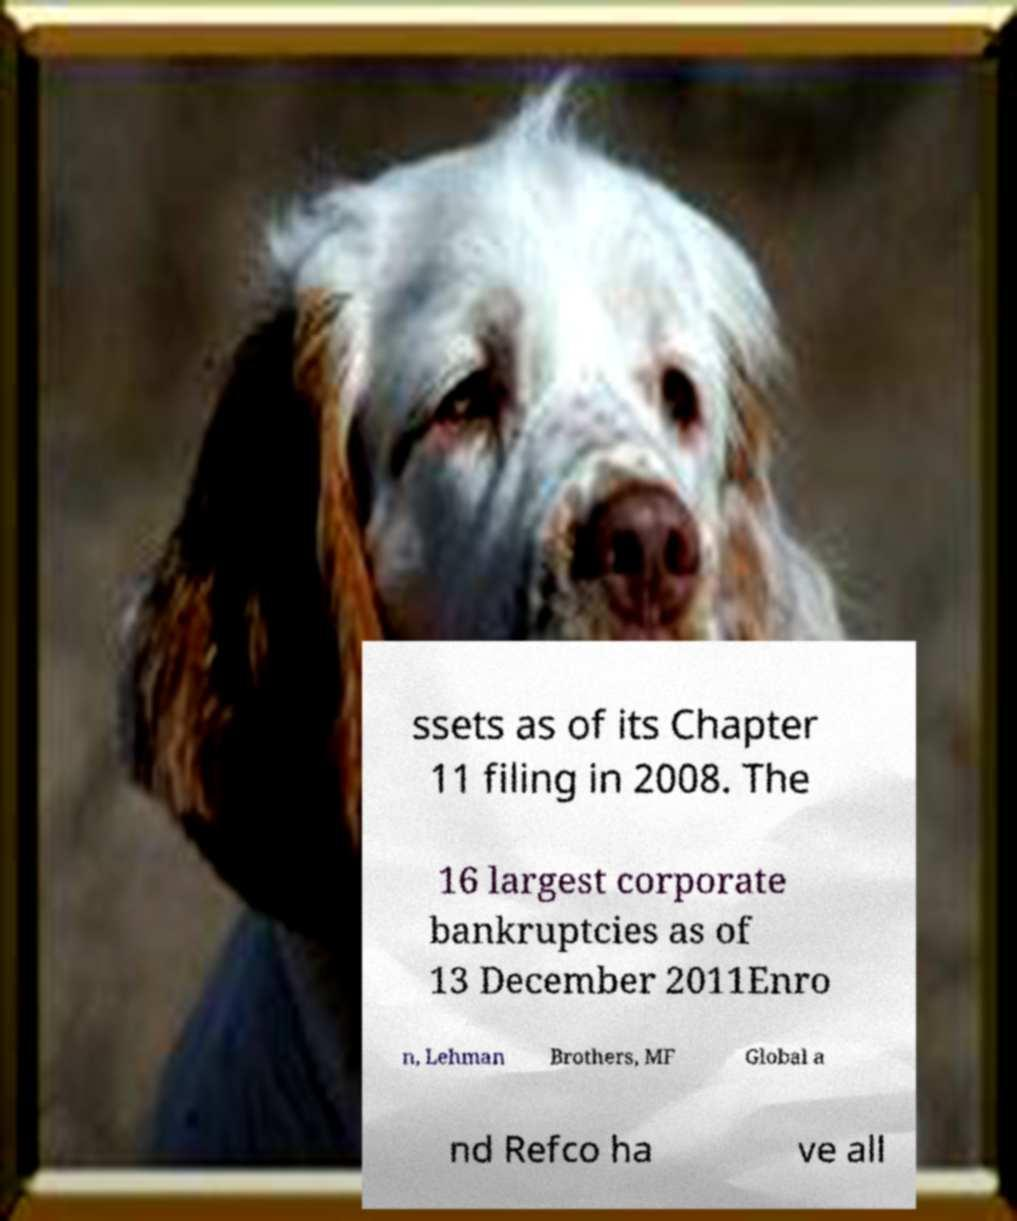What messages or text are displayed in this image? I need them in a readable, typed format. ssets as of its Chapter 11 filing in 2008. The 16 largest corporate bankruptcies as of 13 December 2011Enro n, Lehman Brothers, MF Global a nd Refco ha ve all 